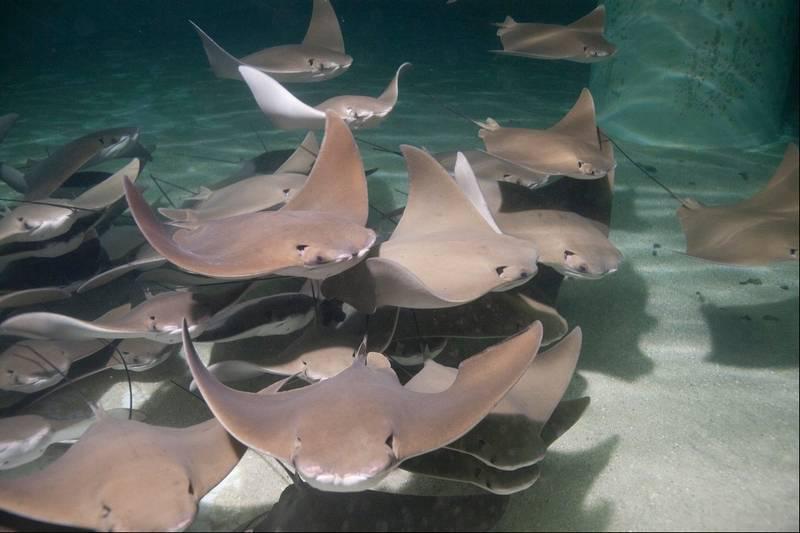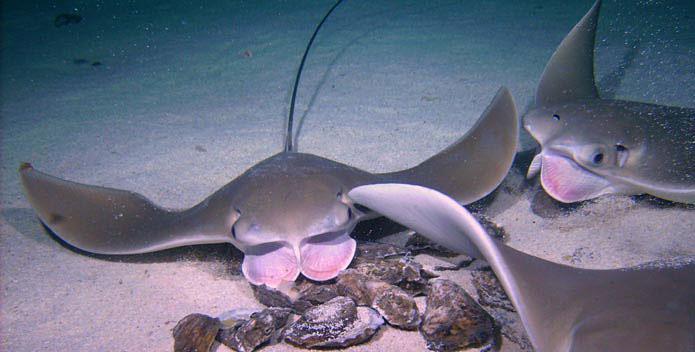The first image is the image on the left, the second image is the image on the right. Considering the images on both sides, is "Has atleast one image with more than 2 stingrays" valid? Answer yes or no. Yes. The first image is the image on the left, the second image is the image on the right. Given the left and right images, does the statement "There are no more than 3 sting rays total." hold true? Answer yes or no. No. 